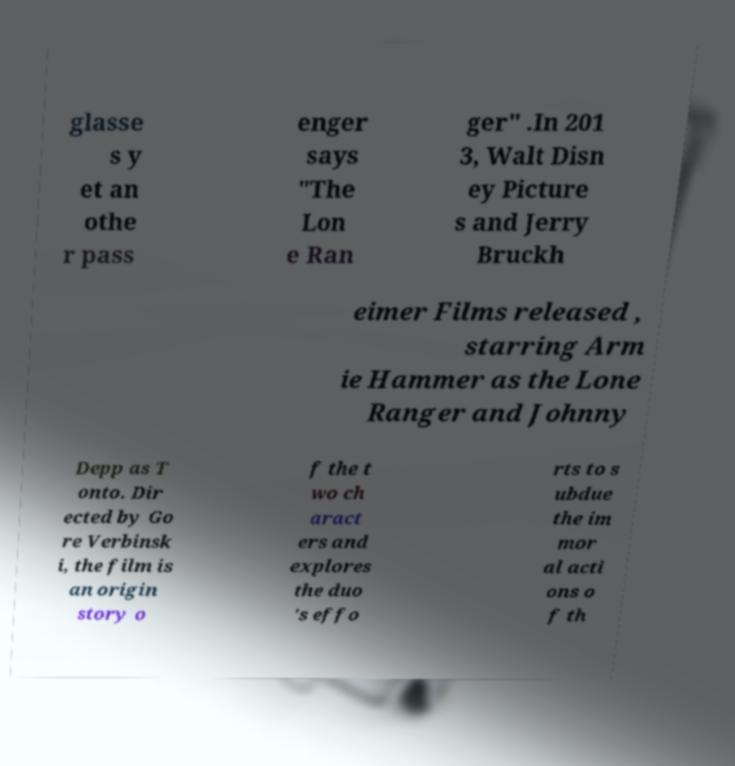Can you accurately transcribe the text from the provided image for me? glasse s y et an othe r pass enger says "The Lon e Ran ger" .In 201 3, Walt Disn ey Picture s and Jerry Bruckh eimer Films released , starring Arm ie Hammer as the Lone Ranger and Johnny Depp as T onto. Dir ected by Go re Verbinsk i, the film is an origin story o f the t wo ch aract ers and explores the duo 's effo rts to s ubdue the im mor al acti ons o f th 